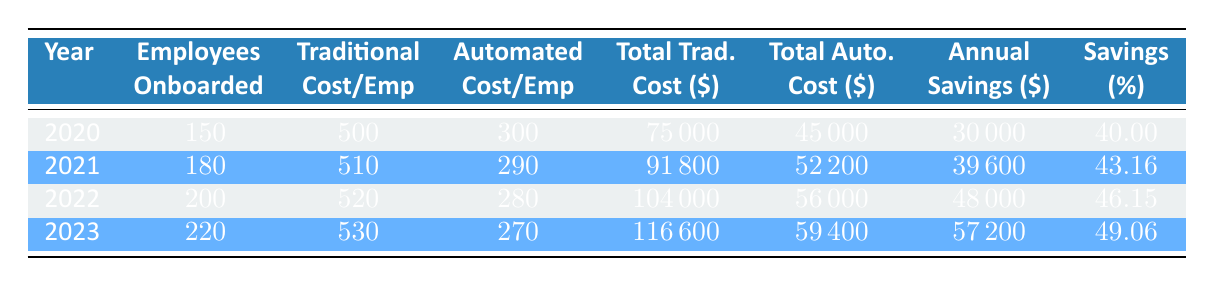What was the total annual savings in 2022? The annual savings for 2022 is explicitly listed in the table under the heading "Annual Savings". In the row for the year 2022, the annual savings amount is 48000.
Answer: 48000 What is the percentage of savings from automated onboarding processes in 2021? The savings percentage for 2021 is directly shown in the table. In the row for the year 2021, the savings percentage is 43.16.
Answer: 43.16 In which year did the company onboard the most employees? To find the year with the most employees onboarded, I must compare the "Total Employees Onboarded" values across all years. The highest value is 220 in 2023.
Answer: 2023 What is the difference in total costs between traditional and automated onboarding in 2023? To find the difference, I will take the total cost of traditional onboarding (116600) and subtract the total cost of automated onboarding (59400): 116600 - 59400 = 57200.
Answer: 57200 Did the annual savings increase each year from 2020 to 2023? By examining the annual savings for each year listed in the table, I can see that it starts at 30000 in 2020 and increases to 57200 in 2023. Therefore, the annual savings did increase each year.
Answer: Yes What is the average cost per employee for traditional onboarding from 2020 to 2023? To find the average, I'll add the costs for each year: (500 + 510 + 520 + 530) = 2060. Then I'll divide by the number of years (4): 2060 / 4 = 515.
Answer: 515 What percentage of savings was achieved through automated onboarding in 2020? The savings percentage for 2020 is provided in the table. Referring to the row for 2020, the savings percentage is 40.00.
Answer: 40.00 What was the total cost of automated onboarding in 2021 compared to 2022? The total cost for automated onboarding in 2021 is 52200 and for 2022 is 56000. Comparing these two, I find that 52200 in 2021 is less than 56000 in 2022, indicating an increase.
Answer: 56000 In which year was the savings percentage higher than 45%? I will check the savings percentages for each year. In 2022, it is 46.15 and in 2023, it is 49.06—both higher than 45%.
Answer: 2022 and 2023 